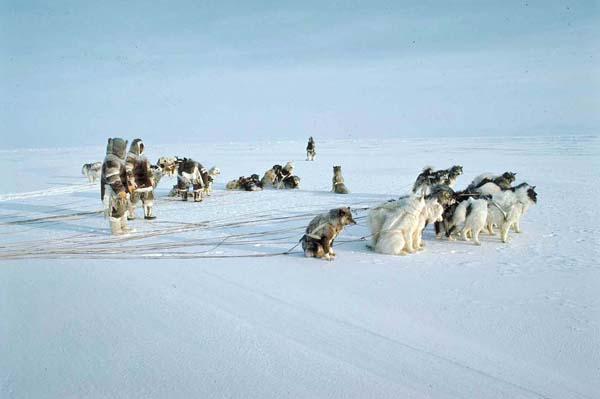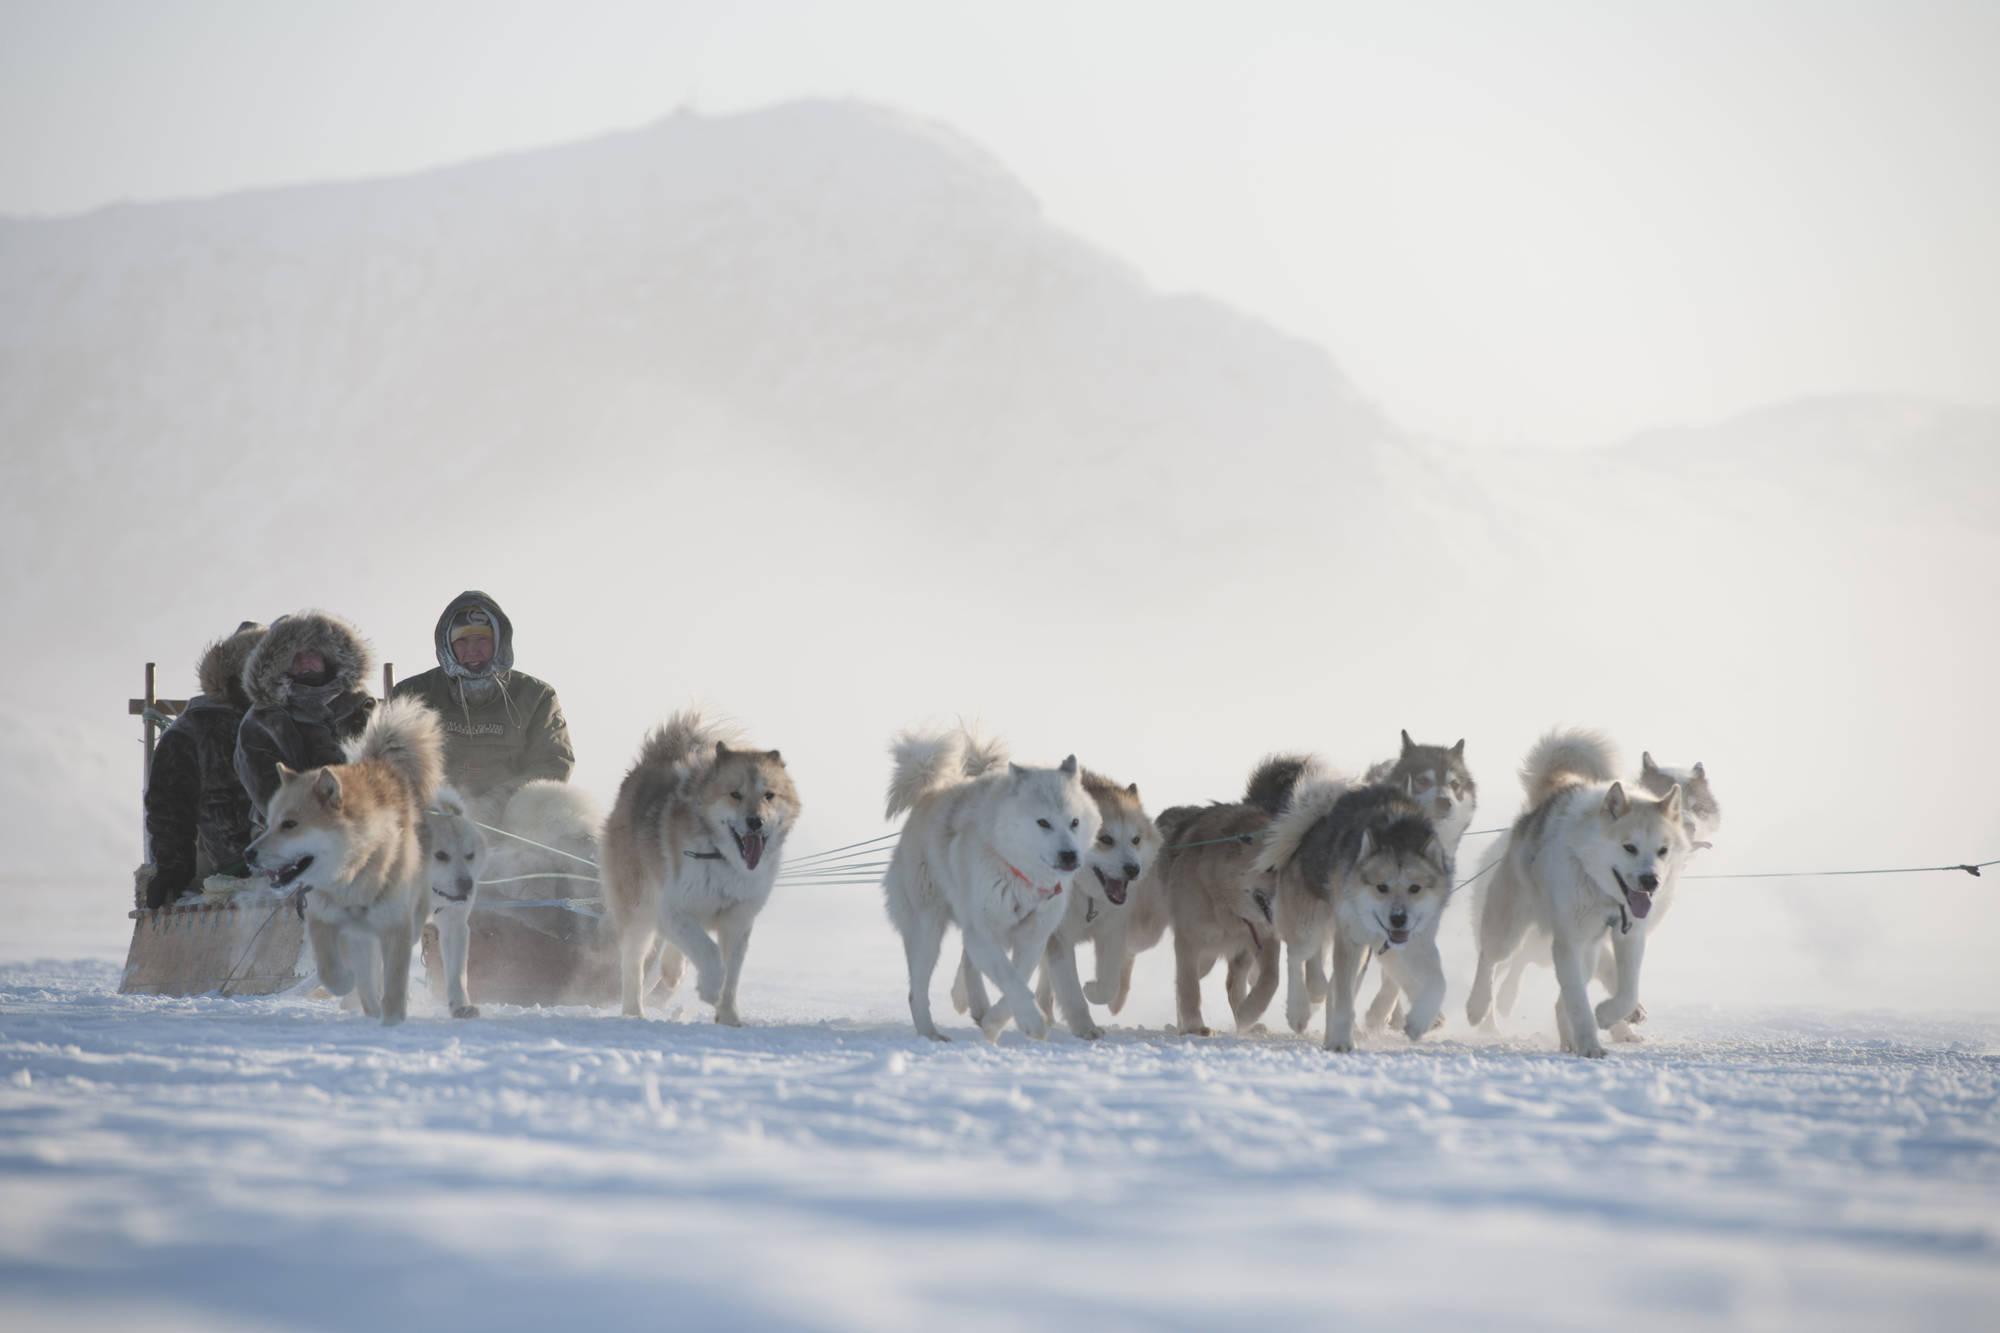The first image is the image on the left, the second image is the image on the right. Evaluate the accuracy of this statement regarding the images: "There are dogs resting.". Is it true? Answer yes or no. Yes. The first image is the image on the left, the second image is the image on the right. For the images shown, is this caption "Some of the dogs are sitting." true? Answer yes or no. Yes. 